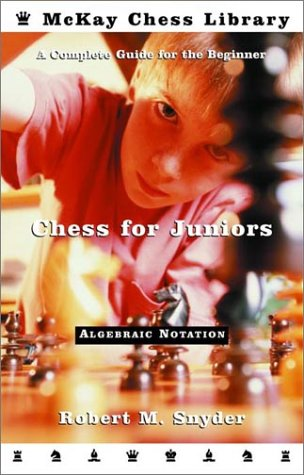Can you describe the cover design of this chess book? The cover features a focused young player analyzing a chessboard, symbolizing the strategic thinking chess requires. The imagery suggests the book is tailored to help young beginners develop their chess skills. 